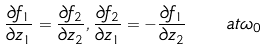<formula> <loc_0><loc_0><loc_500><loc_500>\frac { \partial { f } _ { 1 } } { \partial { z } _ { 1 } } = \frac { \partial { f } _ { 2 } } { \partial { z } _ { 2 } } , \frac { \partial { f } _ { 2 } } { \partial { z } _ { 1 } } = - \frac { \partial { f } _ { 1 } } { \partial { z } _ { 2 } } \quad a t \omega _ { 0 }</formula> 